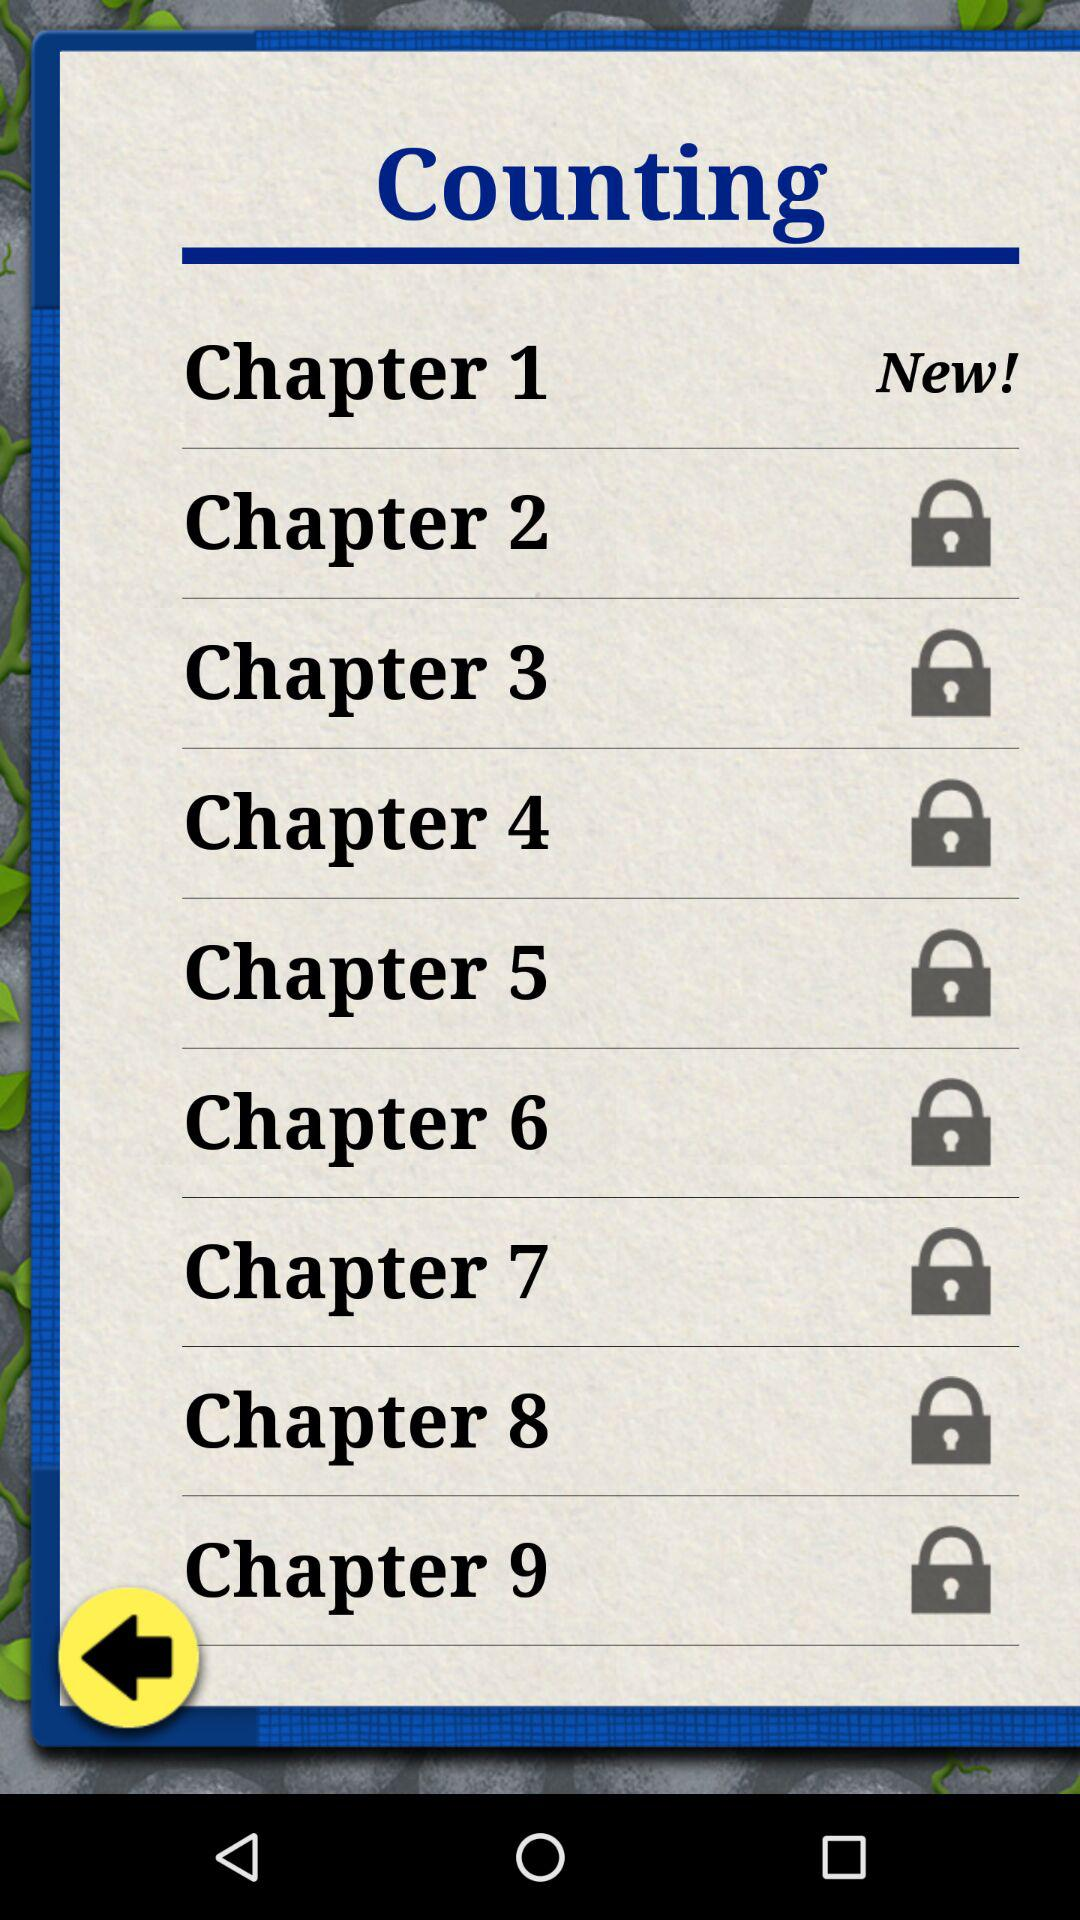What is the status of "Chapter 2"? The status of "Chapter 2" is "Locked". 